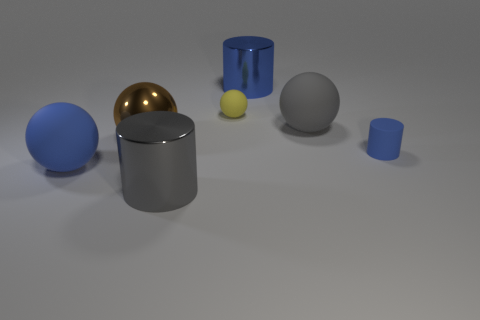There is a metal cylinder that is in front of the blue metal object; is its size the same as the large brown metal sphere?
Provide a succinct answer. Yes. What is the shape of the object that is both on the right side of the shiny ball and in front of the tiny blue cylinder?
Provide a succinct answer. Cylinder. There is a metallic ball; are there any tiny rubber objects in front of it?
Provide a short and direct response. Yes. Does the small blue rubber thing have the same shape as the gray rubber thing?
Offer a terse response. No. Are there the same number of yellow rubber objects that are in front of the yellow rubber sphere and large things that are behind the big gray rubber ball?
Offer a very short reply. No. What number of other objects are the same material as the blue sphere?
Your answer should be very brief. 3. What number of big objects are either blue metal objects or green matte cubes?
Your answer should be very brief. 1. Are there an equal number of blue things that are in front of the brown thing and big matte things?
Provide a succinct answer. Yes. Are there any shiny objects right of the small matte sphere that is left of the large blue shiny object?
Provide a succinct answer. Yes. What number of other things are there of the same color as the rubber cylinder?
Your answer should be very brief. 2. 